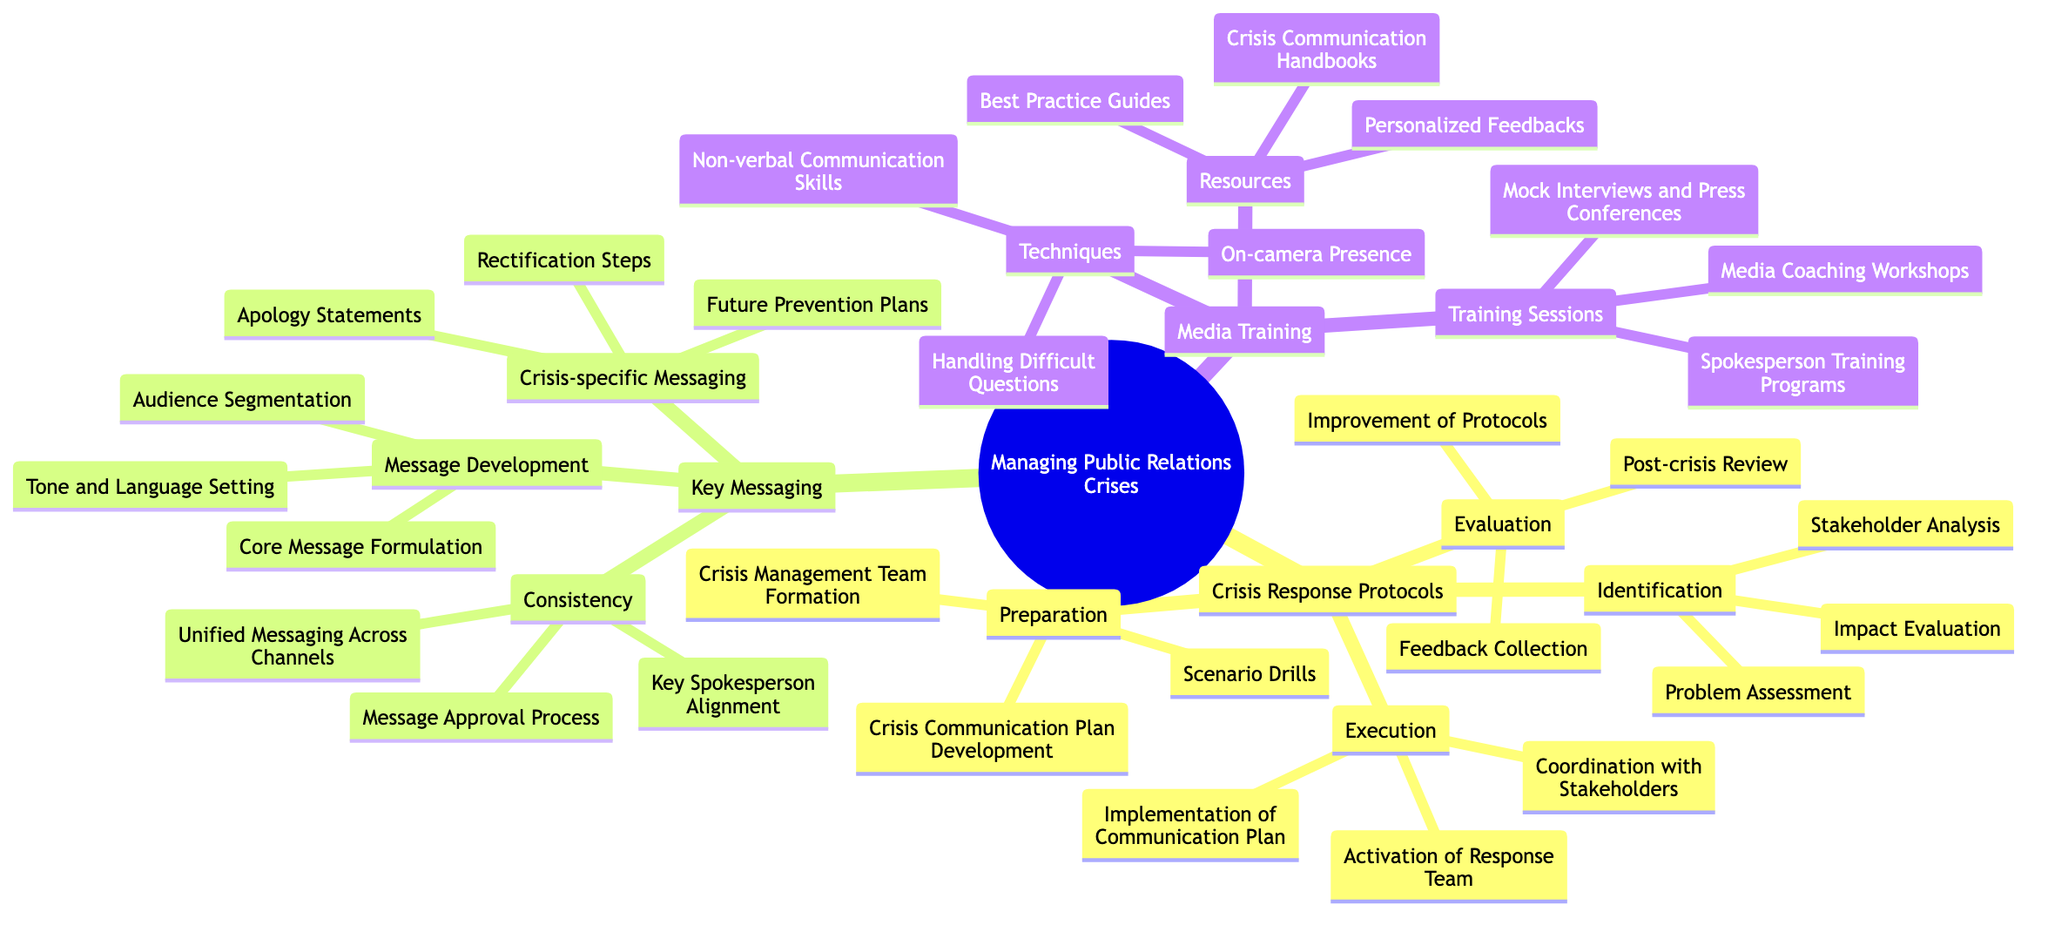What are the key components of Crisis Response Protocols? The diagram indicates that Crisis Response Protocols include four main components: Identification, Preparation, Execution, and Evaluation.
Answer: Identification, Preparation, Execution, Evaluation How many elements are included in Media Training's Techniques? The Techniques section under Media Training lists three specific elements: Handling Difficult Questions, Non-verbal Communication Skills, and On-camera Presence.
Answer: 3 What is one type of message included in Crisis-specific Messaging? The Key Messaging section under Crisis-specific Messaging includes Apology Statements, which is one type of message mentioned.
Answer: Apology Statements Which node contains the message development elements? The diagram shows that Message Development is a subsection under Key Messaging, which specifically contains Core Message Formulation, Audience Segmentation, and Tone and Language Setting as elements.
Answer: Message Development What is the purpose of scenario drills in the Preparedness stage? The diagram specifies that Scenario Drills are included under the Preparation category, suggesting they serve as a means to prepare for crises by simulating potential situations.
Answer: Preparation How many components are under Identification in Crisis Response Protocols? The Identification section of Crisis Response Protocols enumerates three components: Problem Assessment, Stakeholder Analysis, and Impact Evaluation.
Answer: 3 What does the Evaluation phase of Crisis Response Protocols involve? The Evaluation phase includes Post-crisis Review, Feedback Collection, and Improvement of Protocols, indicating areas for analysis after a crisis event.
Answer: Post-crisis Review, Feedback Collection, Improvement of Protocols What key resource is part of Media Training's Resources? The Resources section within Media Training lists multiple materials, one of which is Crisis Communication Handbooks.
Answer: Crisis Communication Handbooks How many types of training sessions are included in Media Training? The diagram outlines that the Training Sessions section has three types of training: Media Coaching Workshops, Spokesperson Training Programs, and Mock Interviews and Press Conferences.
Answer: 3 